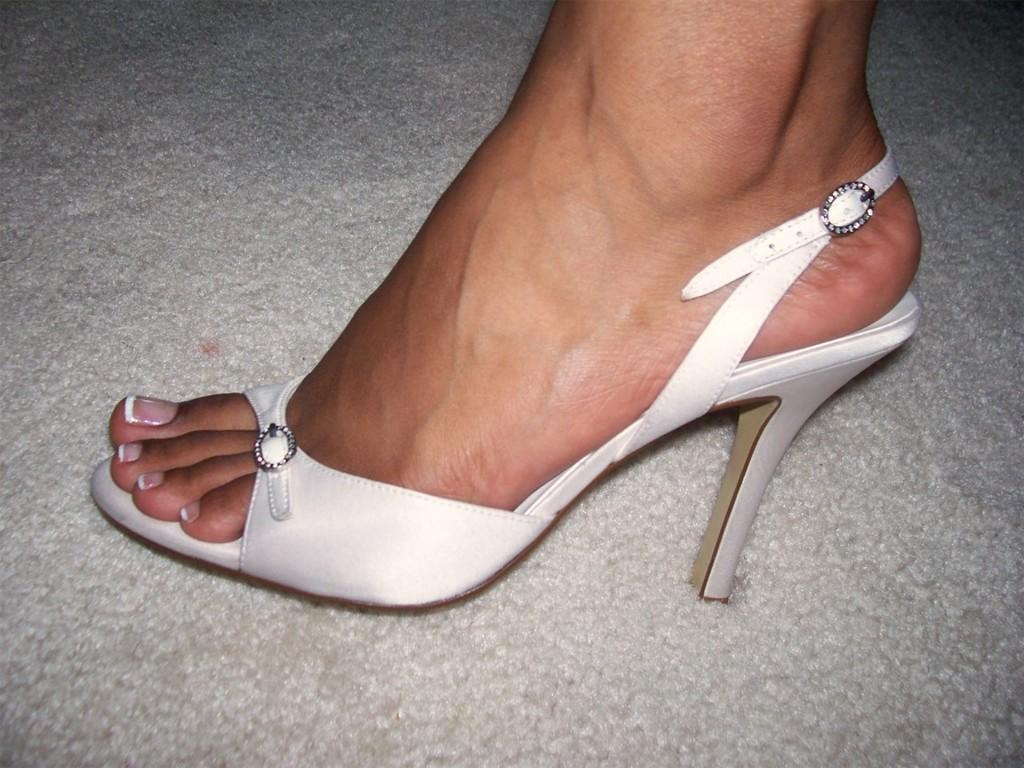How would you summarize this image in a sentence or two? In this image we can see a leg of a person. A person is wearing a footwear. 